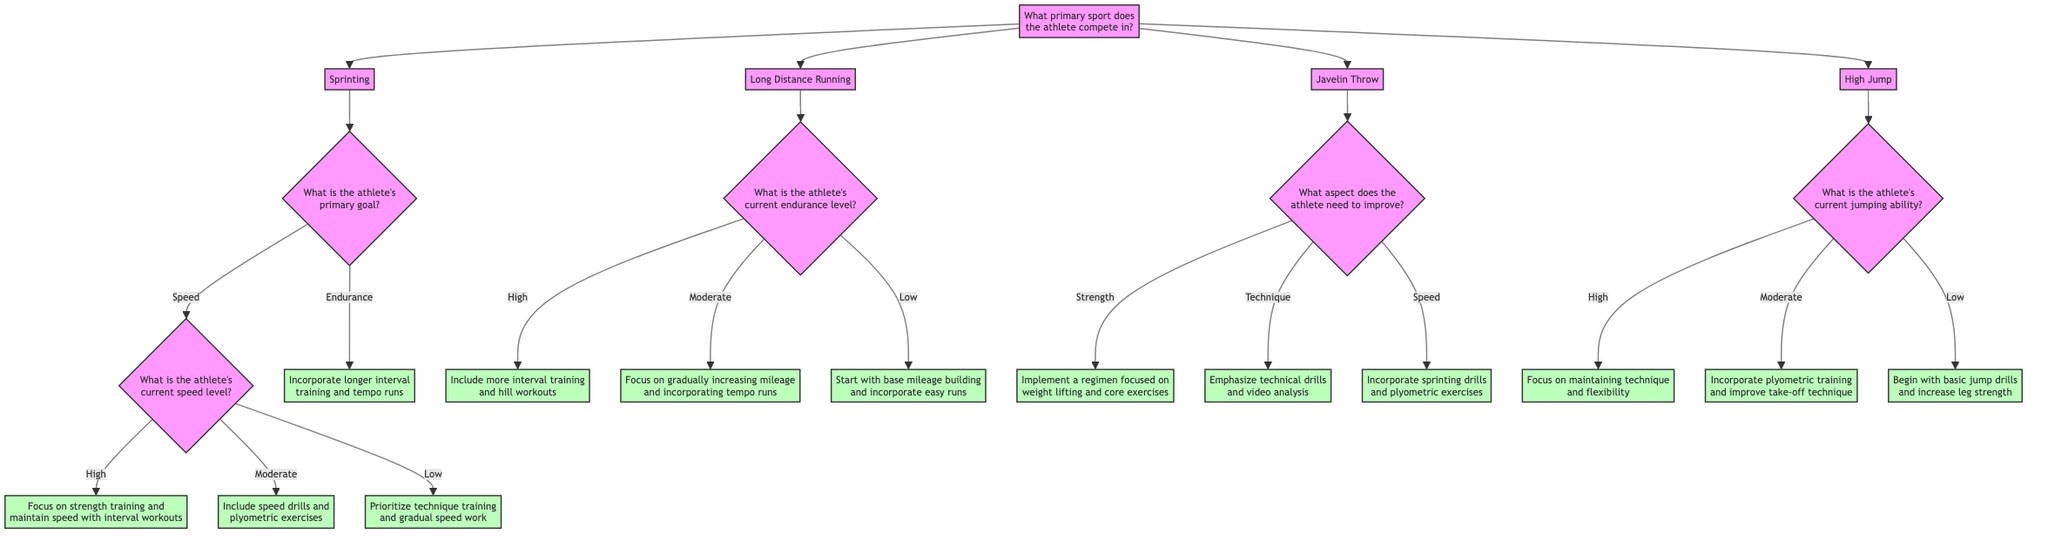What is the primary question at the root of the diagram? The root of the diagram asks, "What primary sport does the athlete compete in?" This is the first decision point that leads to further questions based on the athlete's chosen sport.
Answer: What primary sport does the athlete compete in? How many sports are represented in the diagram? The diagram includes four sports: Sprinting, Long Distance Running, Javelin Throw, and High Jump. This can be counted directly from the primary options stemming from the root node.
Answer: Four What should an athlete focusing on speed in Sprinting do if their current speed level is low? An athlete with a low speed level in Sprinting should prioritize technique training and gradual speed work, as specified in the recommendation at that branch of the decision tree.
Answer: Prioritize technique training and gradual speed work If an athlete in Long Distance Running has a moderate endurance level, what is recommended? For an athlete with a moderate endurance level in Long Distance Running, the recommendation is to focus on gradually increasing mileage and incorporating tempo runs. This is found directly in the appropriate node under Long Distance Running.
Answer: Focus on gradually increasing mileage and incorporating tempo runs What is the relationship between the primary goal and the current speed level in Sprinting? The primary goal in Sprinting determines the next set of questions that the athlete faces: either to assess speed or endurance, which leads to different training recommendations based on their current abilities. Speed and endurance are two main branches stemming from the goal which further dictate the training focus.
Answer: It determines the next set of questions What should an athlete focused on improving technique in Javelin Throw do? An athlete focused on improving technique in Javelin Throw should emphasize technical drills and video analysis, according to the recommendation directly related to that option in the decision tree.
Answer: Emphasize technical drills and video analysis What training focus is suggested for an athlete in High Jump with high jumping ability? An athlete with high jumping ability in High Jump should focus on maintaining technique and flexibility. This is outlined as a direct recommendation under the respective node for high jumping ability.
Answer: Focus on maintaining technique and flexibility What happens if an athlete in Javelin Throw wants to improve their strength? If an athlete in Javelin Throw wants to improve their strength, the recommendation is to implement a regimen focused on weight lifting and core exercises, as indicated in the decision tree for that aspect of training.
Answer: Implement a regimen focused on weight lifting and core exercises 